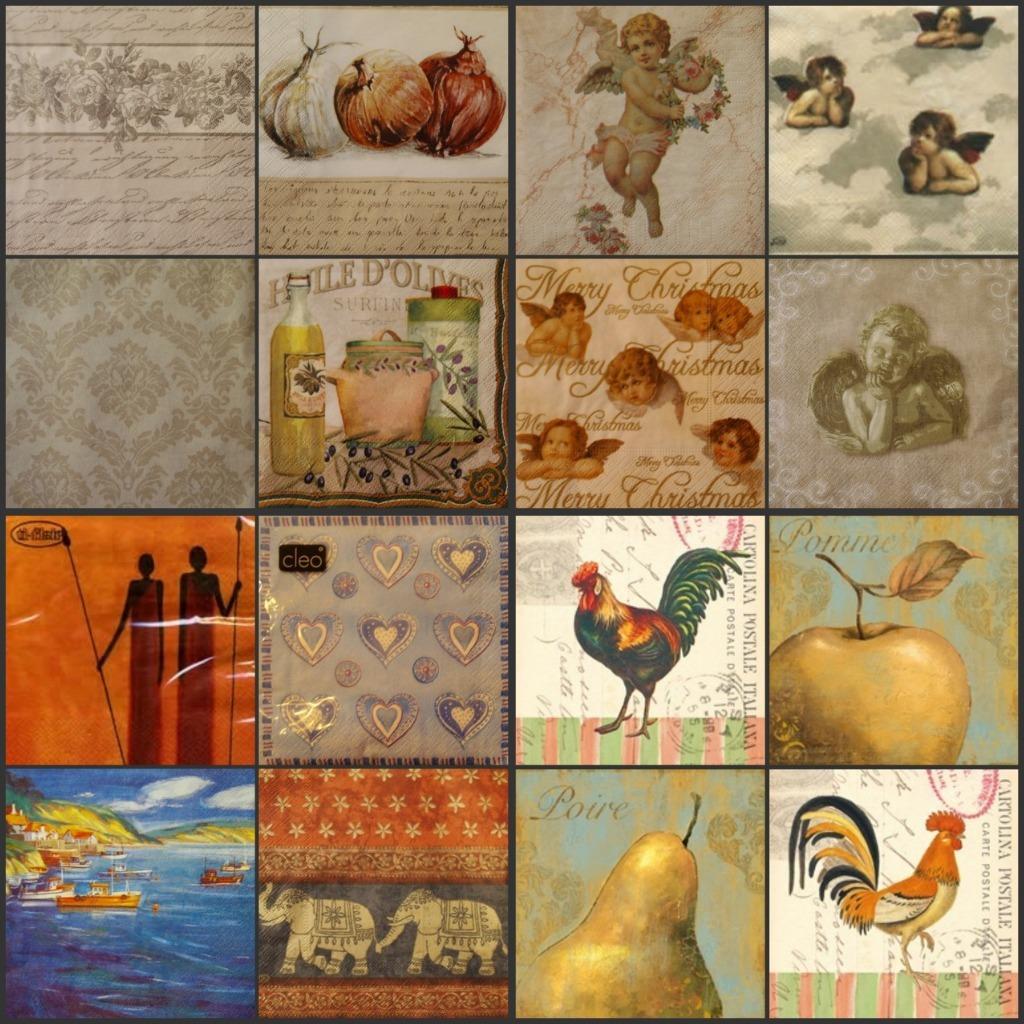Could you give a brief overview of what you see in this image? This is a collage image of 8 pictures, which includes angels, hen, pear, apple and etc. 